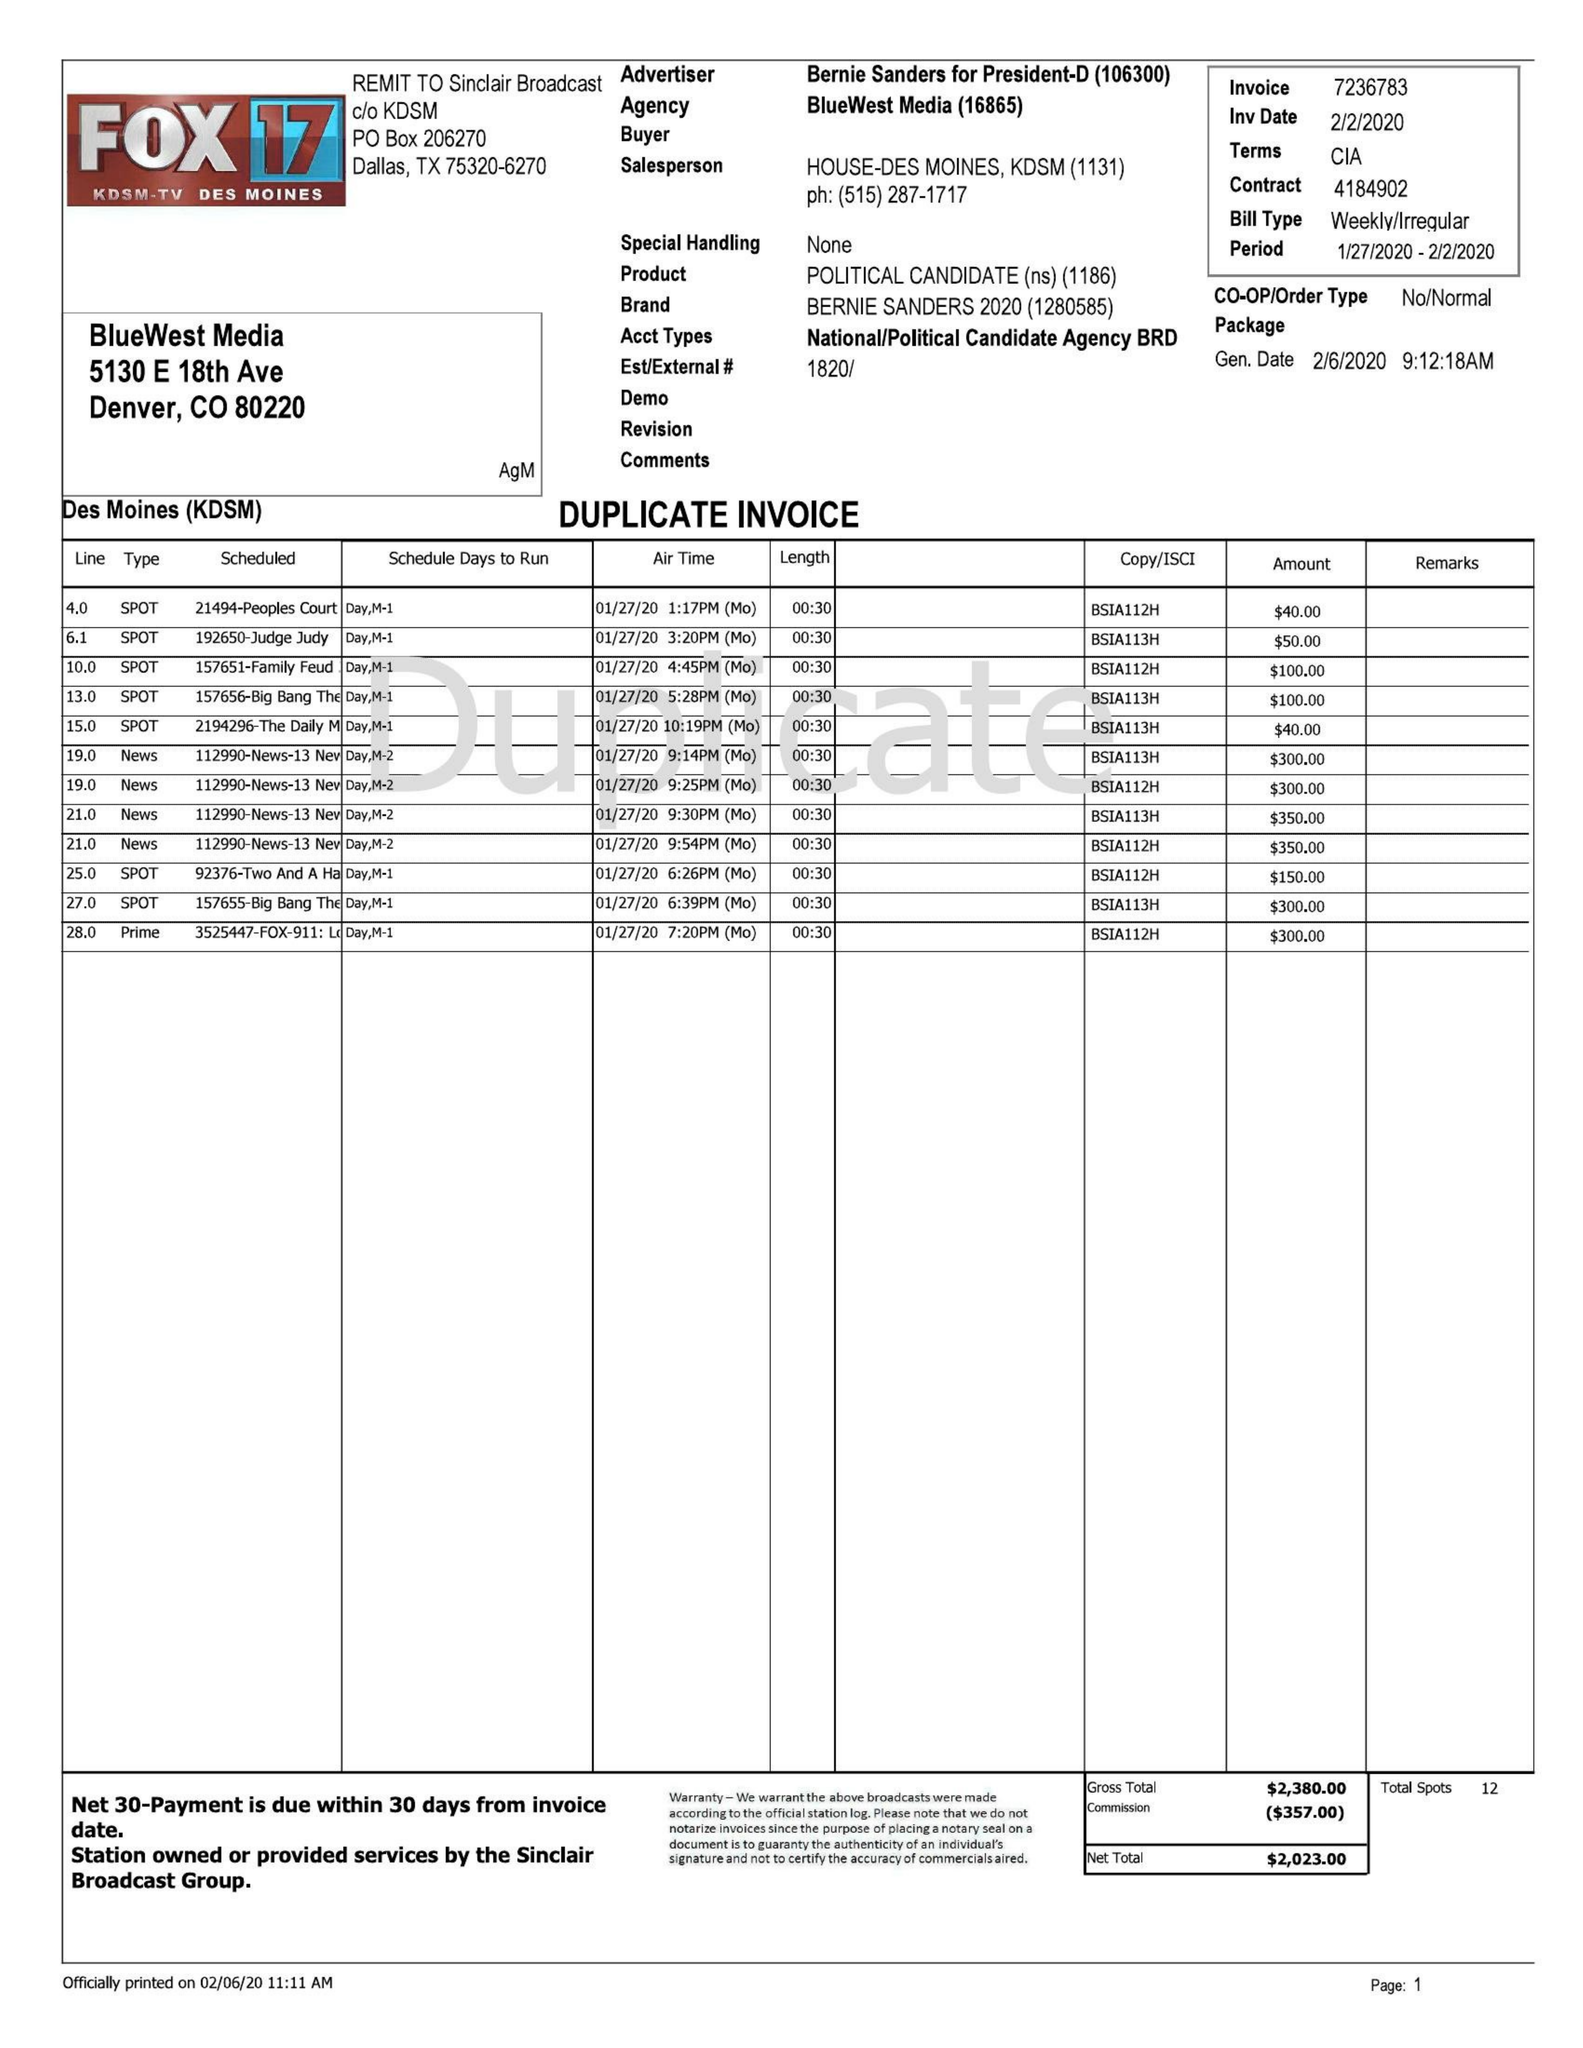What is the value for the flight_to?
Answer the question using a single word or phrase. 02/02/20 